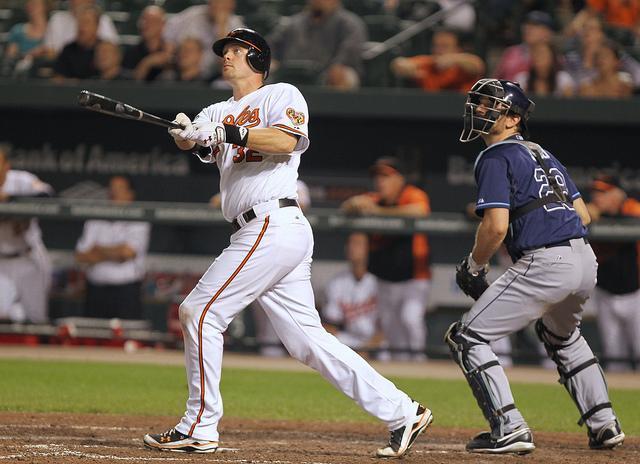How many people are in the picture?
Give a very brief answer. 10. How many giraffes are there?
Give a very brief answer. 0. 